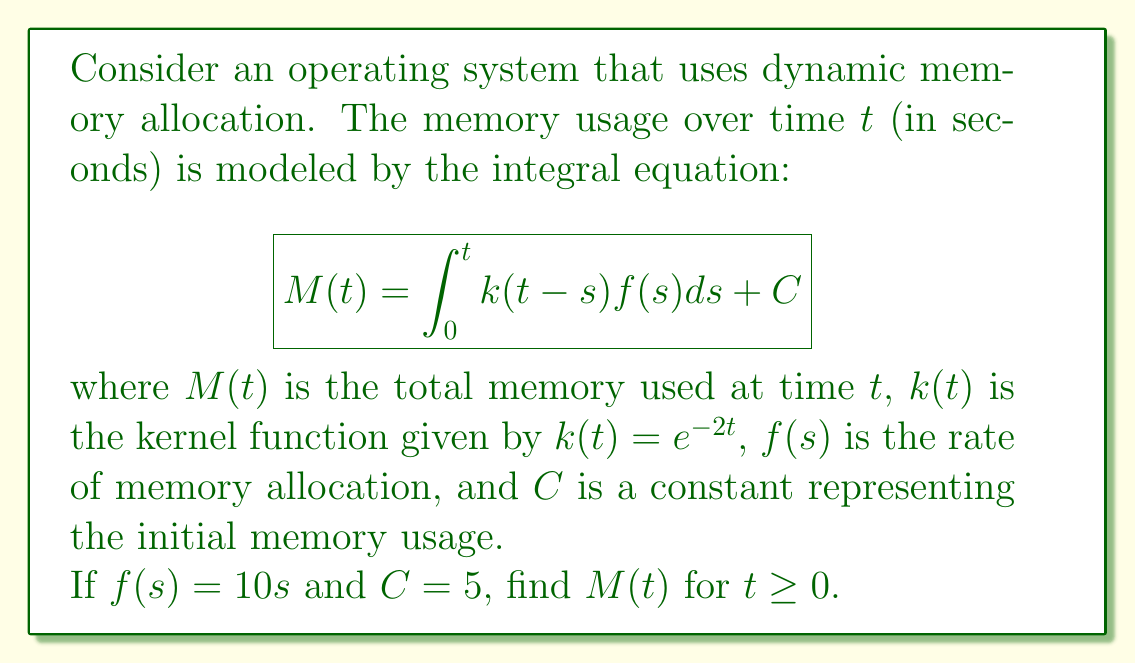Help me with this question. To solve this integral equation, let's follow these steps:

1) First, we substitute the given functions into the equation:
   $$M(t) = \int_0^t e^{-2(t-s)}(10s)ds + 5$$

2) Let's solve the integral:
   $$\int_0^t e^{-2(t-s)}(10s)ds = 10e^{-2t}\int_0^t se^{2s}ds$$

3) To solve this integral, we can use integration by parts. Let $u = s$ and $dv = e^{2s}ds$:
   $$10e^{-2t}[\frac{1}{2}se^{2s} - \frac{1}{4}\int e^{2s}ds]_0^t$$

4) Evaluating the integral:
   $$10e^{-2t}[\frac{1}{2}se^{2s} - \frac{1}{8}e^{2s}]_0^t$$

5) Applying the limits:
   $$10e^{-2t}[(\frac{1}{2}te^{2t} - \frac{1}{8}e^{2t}) - (0 - \frac{1}{8})]$$

6) Simplifying:
   $$10e^{-2t}[\frac{1}{2}te^{2t} - \frac{1}{8}e^{2t} + \frac{1}{8}]$$
   $$= 5t - \frac{5}{4} + \frac{5}{4}e^{-2t}$$

7) Adding the constant $C = 5$:
   $$M(t) = 5t - \frac{5}{4} + \frac{5}{4}e^{-2t} + 5$$
   $$= 5t + \frac{15}{4} + \frac{5}{4}e^{-2t}$$

Thus, we have found the expression for $M(t)$.
Answer: $M(t) = 5t + \frac{15}{4} + \frac{5}{4}e^{-2t}$ 